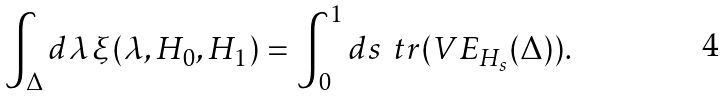Convert formula to latex. <formula><loc_0><loc_0><loc_500><loc_500>\int _ { \Delta } d \lambda \, \xi ( \lambda , H _ { 0 } , H _ { 1 } ) = \int _ { 0 } ^ { 1 } d s \, \ t r ( V E _ { H _ { s } } ( \Delta ) ) .</formula> 